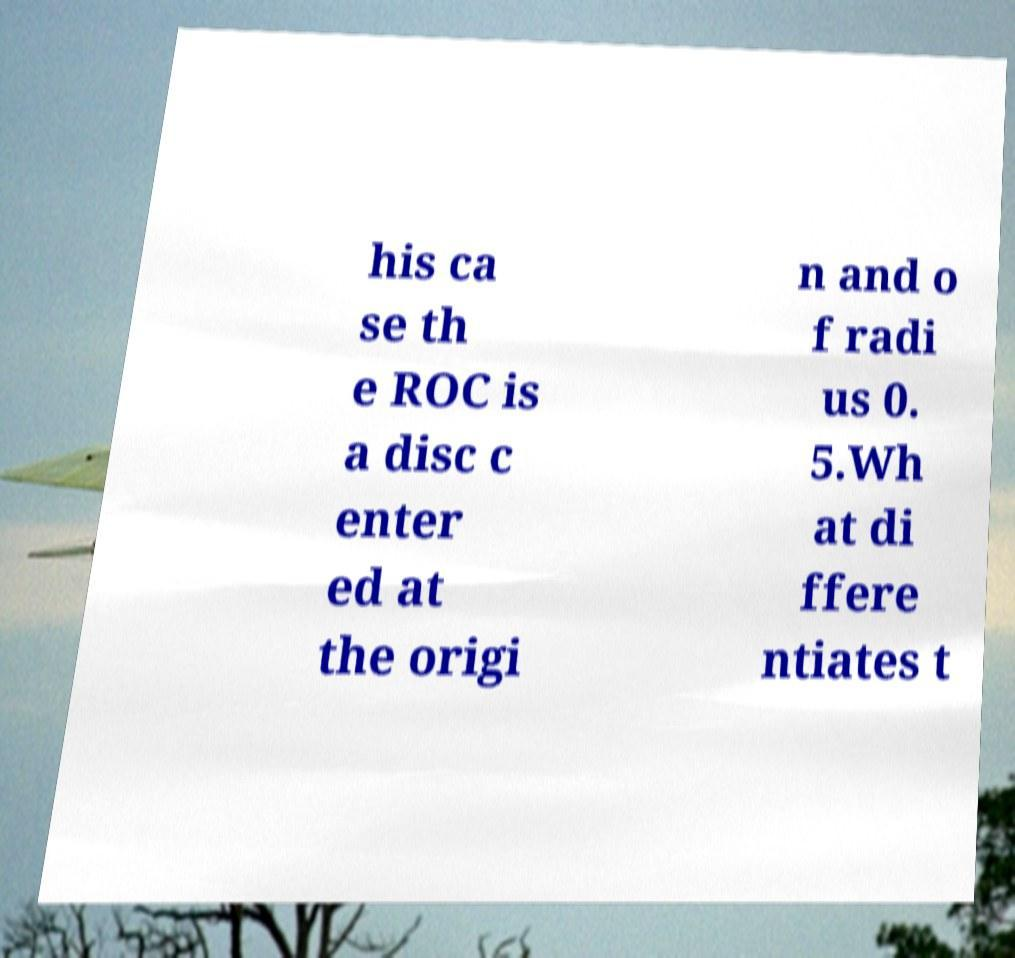Can you read and provide the text displayed in the image?This photo seems to have some interesting text. Can you extract and type it out for me? his ca se th e ROC is a disc c enter ed at the origi n and o f radi us 0. 5.Wh at di ffere ntiates t 